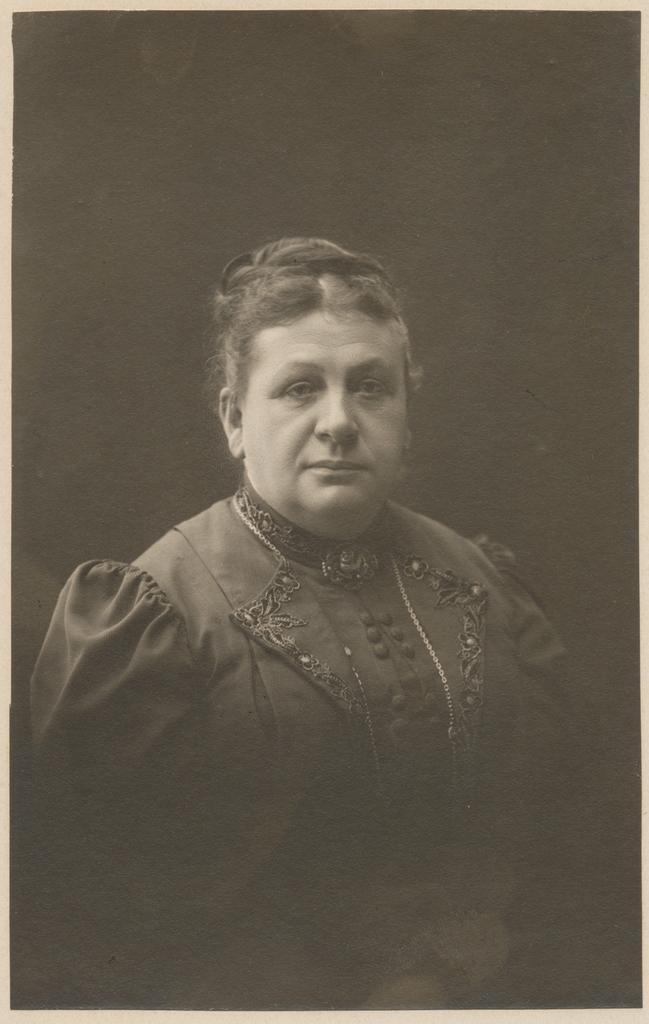Please provide a concise description of this image. This is a black and white picture of a woman. 